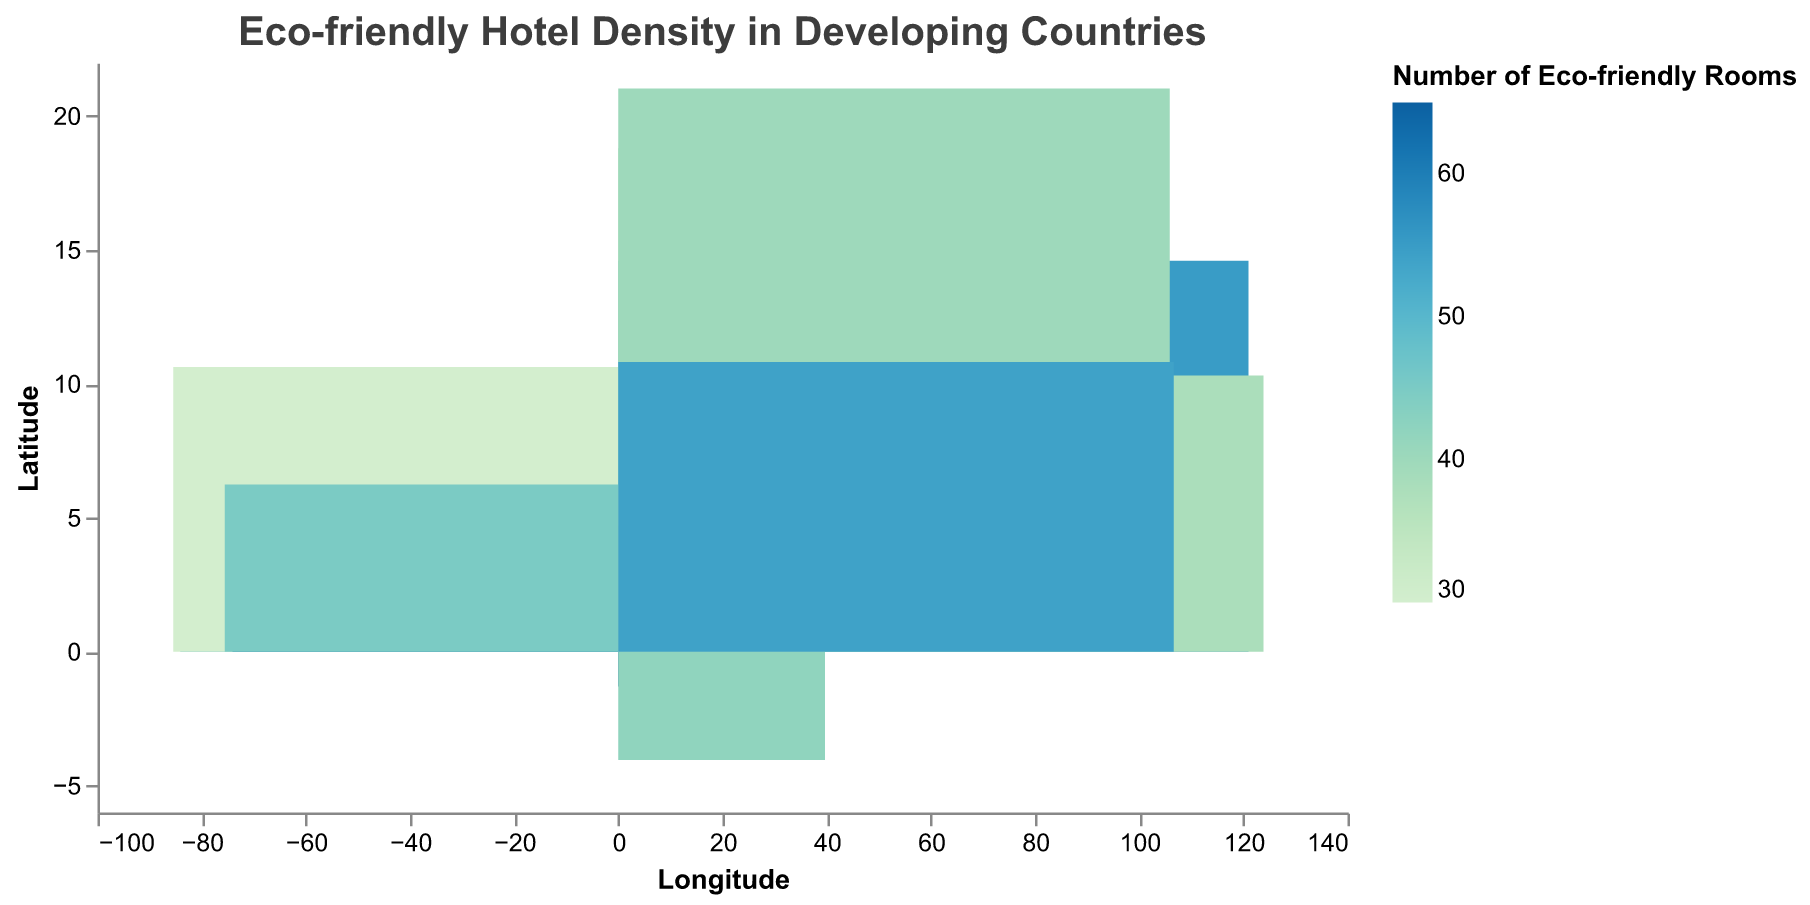How many eco-friendly rooms are there in "The Green Haven" hotel in Nairobi, Kenya? Look at the tooltip for Nairobi in Kenya, specifically "The Green Haven" hotel, and you will find the number of eco-friendly rooms listed.
Answer: 65 Which city and country have the highest number of eco-friendly rooms? Identify the hotel with the darkest color in the heatmap which represents the highest value under "Number of Eco-friendly Rooms". Check the tooltip for the highest value to determine the city and country.
Answer: Nairobi, Kenya What is the average occupancy rate for eco-friendly rooms at "Eco Central Hotel" in Bogota, Colombia? Locate Bogota, Colombia on the heatmap and hover over "Eco Central Hotel" to find the average occupancy rate displayed in the tooltip.
Answer: 82% Compare the number of eco-friendly rooms between "Urban Eco Hotel" in Manila, Philippines and "Sustainable Stay Hotel" in Hanoi, Vietnam. Which one has more? Find and compare the color-coded values for the two hotels in their respective locations. Check the tooltips to confirm.
Answer: Urban Eco Hotel in Manila Which country features two cities with significant eco-friendly hotel density, and what are those cities? For countries with more than one data point, check the number of eco-friendly rooms for each city. Identify the cities in countries that have multiple significant density points.
Answer: Kenya: Nairobi and Mombasa What's the difference in the number of eco-friendly rooms between "The Eco Escape" in San Jose, Costa Rica and "Green Urban Oasis" in Bangkok, Thailand? Use the tooltips to find the number of eco-friendly rooms for both hotels and subtract one value from the other.
Answer: 2 Which hotel in Vietnam has a higher average occupancy rate: "Sustainable Stay Hotel" in Hanoi or "Eco Elegance Hotel" in Ho Chi Minh City? Find the respective hotels in the heatmap and compare the average occupancy rates shown in the tooltips.
Answer: Eco Elegance Hotel What appears to be the general trend in the number of eco-friendly rooms based on geographic location (latitude and longitude)? Observe the color variation in different parts of the map (by latitude and longitude) and check if there is a noticeable trend or clustering of eco-friendly rooms in certain areas.
Answer: No clear trend; it varies by specific cities Which country has the highest overall density of eco-friendly hotel rooms based on the heatmap? Aggregate the number of eco-friendly rooms for each country by summing the values shown in the tooltips for each hotel and comparing the totals.
Answer: Kenya For "Nature's Comfort Suites" in Medellin, Colombia, and "Friendly Environment Inn" in Chiang Mai, Thailand, which location has a higher average occupancy rate? Find the tooltip details for each hotel and compare their average occupancy rates.
Answer: Nature's Comfort Suites 